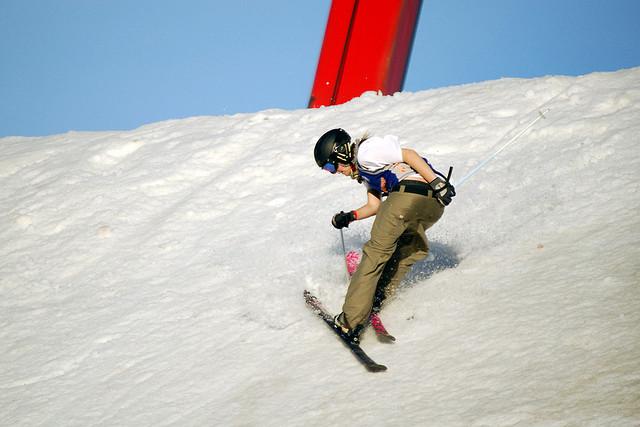Is this an overcast day?
Concise answer only. No. Is the person wearing the right outfit for skiing?
Quick response, please. No. Is this person skiing uphill?
Keep it brief. No. 